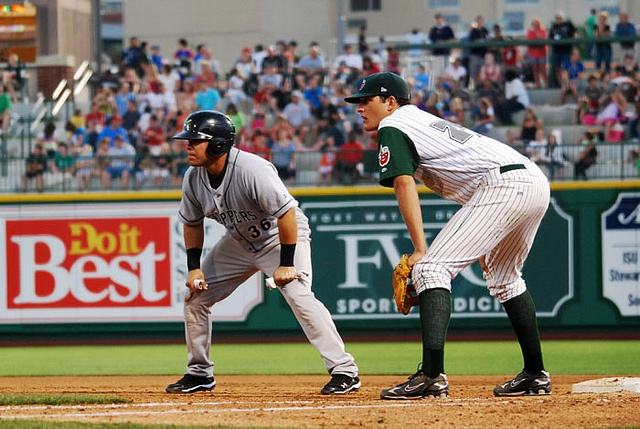Describe the objects in this image and their specific colors. I can see people in gray, darkgray, and black tones, people in gray, lightgray, black, and darkgray tones, people in gray, lightgray, black, and darkgray tones, people in gray, brown, and black tones, and people in gray, black, maroon, and navy tones in this image. 